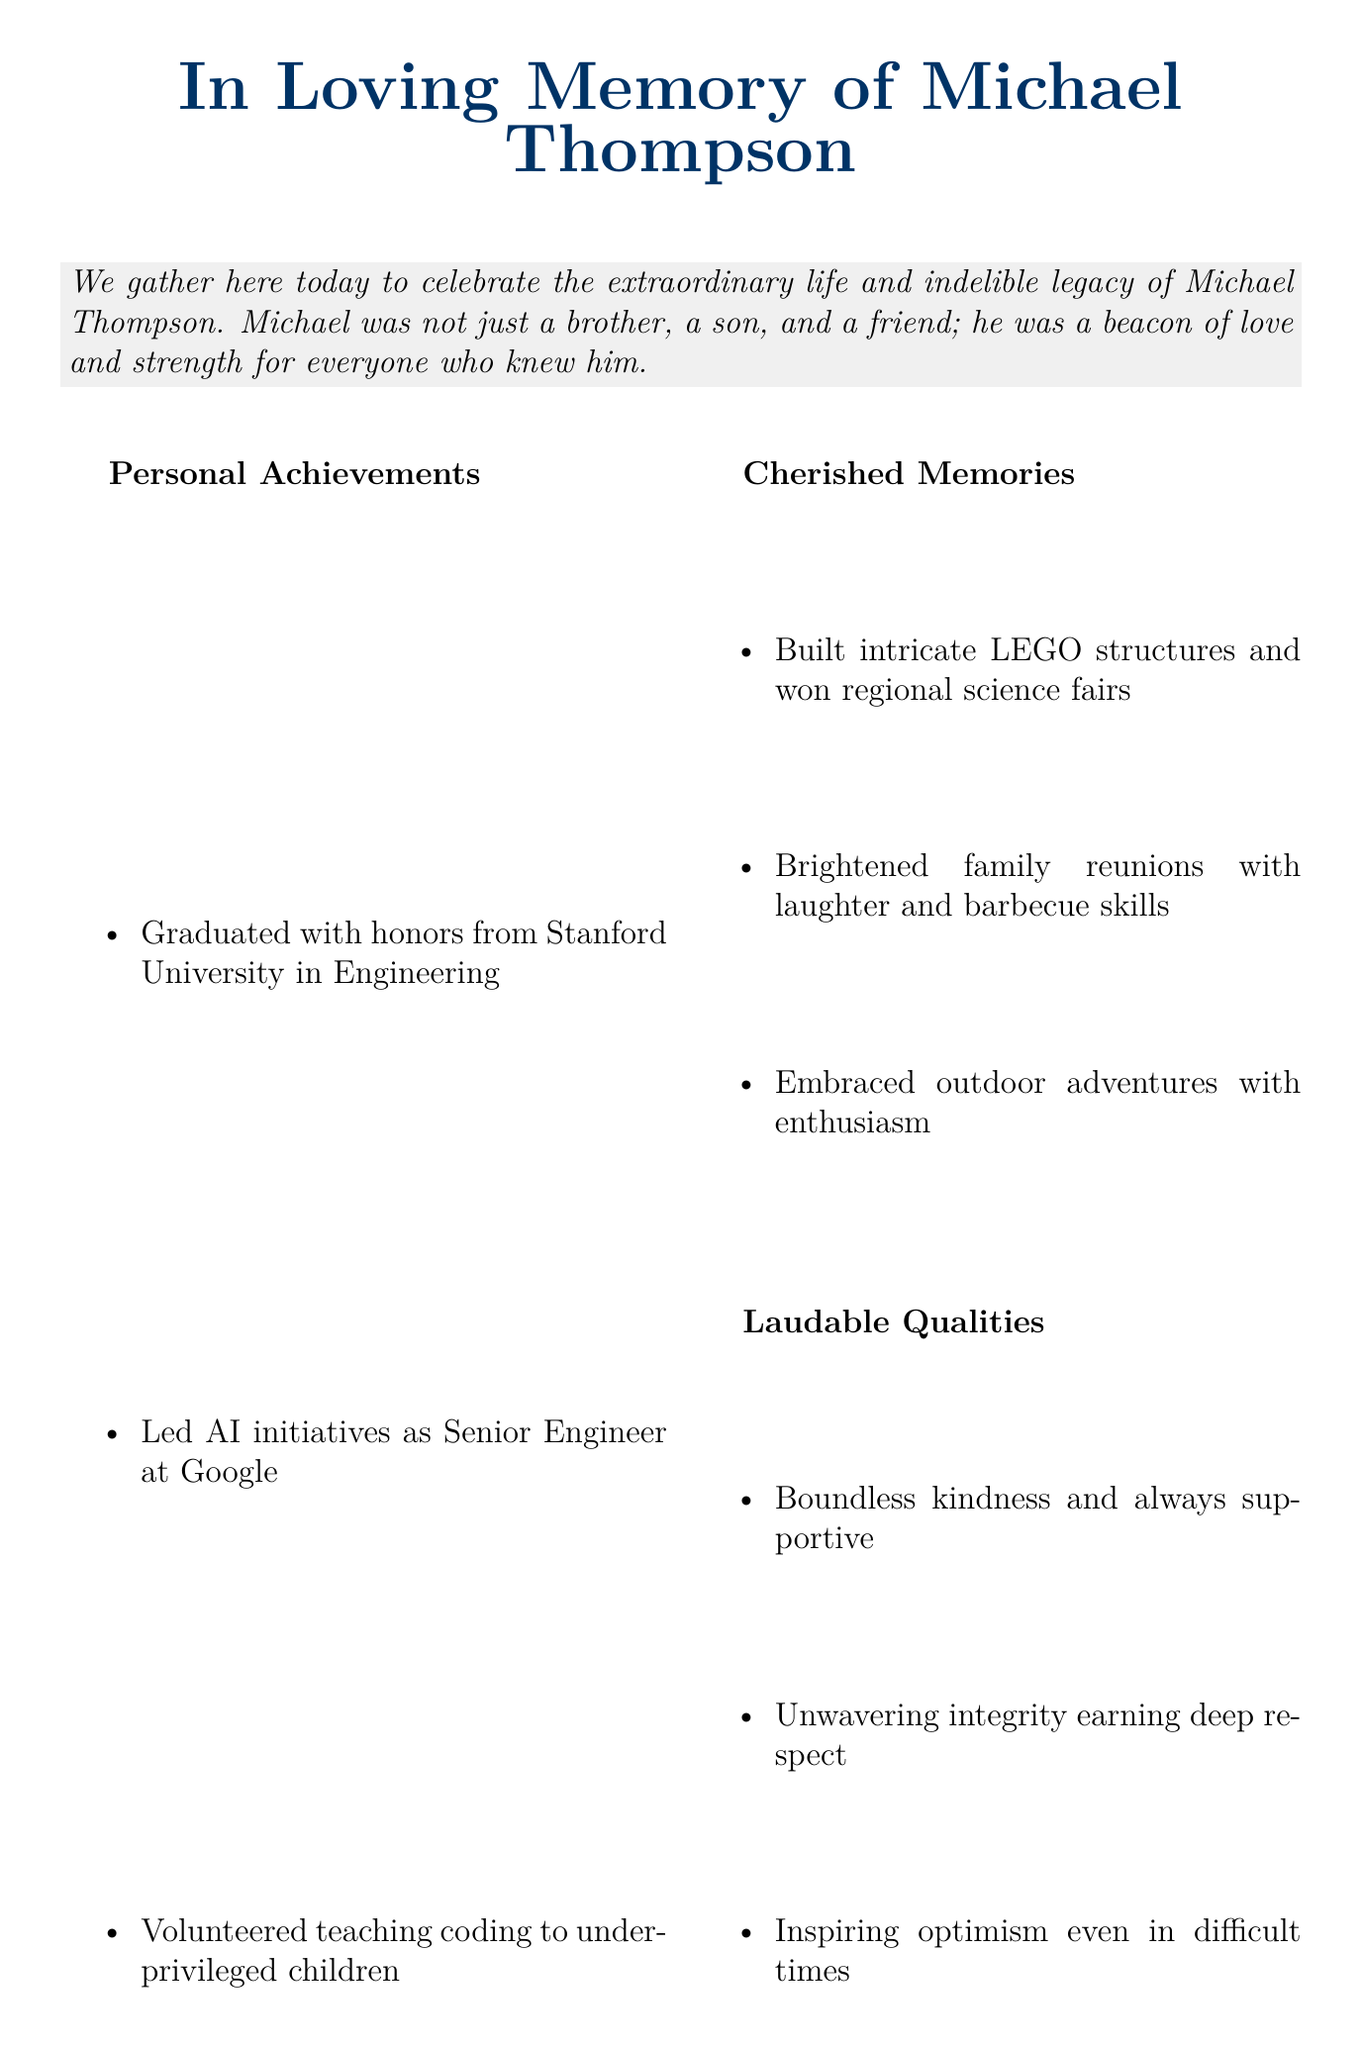What is the full name of the person being honored? The document specifies the name as part of the title in the header section.
Answer: Michael Thompson What university did Michael graduate from? The achievements section lists the university where Michael completed his studies with honors.
Answer: Stanford University What was Michael's profession? The document mentions his work title in the 'Personal Achievements' section.
Answer: Senior Engineer Which skill did Michael teach to children? The document states a specific activity Michael volunteered for in the achievements section.
Answer: Coding What quality is associated with Michael's supportiveness? The laudable qualities section highlights Michael's supportive nature in one specific phrase.
Answer: Boundless kindness What role did Michael play in his family? The positive impact section describes Michael's role in family dynamics.
Answer: The glue Name one of Michael's outdoor activities. The cherished memories section references a specific enthusiasm he had for outdoor activities.
Answer: Adventures How did Michael contribute to the tech community? The document summarizes his influence and contributions in the positive impact section.
Answer: Role model What is the overall theme of Michael's legacy? The conclusion section mentions the overarching themes of Michael's life and character.
Answer: Love and Innovation 